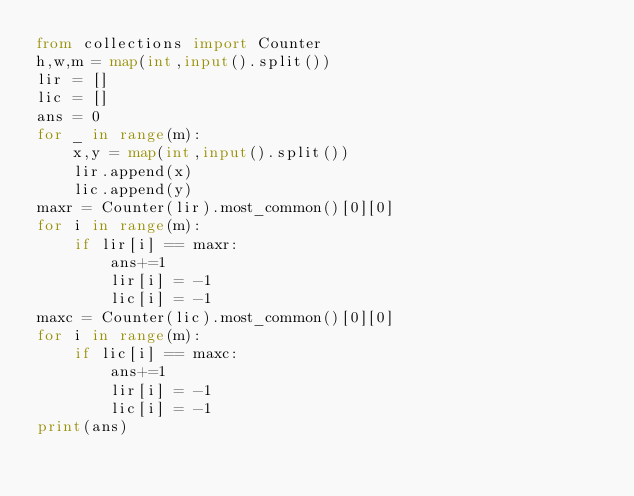<code> <loc_0><loc_0><loc_500><loc_500><_Python_>from collections import Counter
h,w,m = map(int,input().split())
lir = []
lic = []
ans = 0
for _ in range(m):
    x,y = map(int,input().split())
    lir.append(x)
    lic.append(y)
maxr = Counter(lir).most_common()[0][0]
for i in range(m):
    if lir[i] == maxr:
        ans+=1
        lir[i] = -1
        lic[i] = -1
maxc = Counter(lic).most_common()[0][0]
for i in range(m):
    if lic[i] == maxc:
        ans+=1
        lir[i] = -1
        lic[i] = -1
print(ans)</code> 